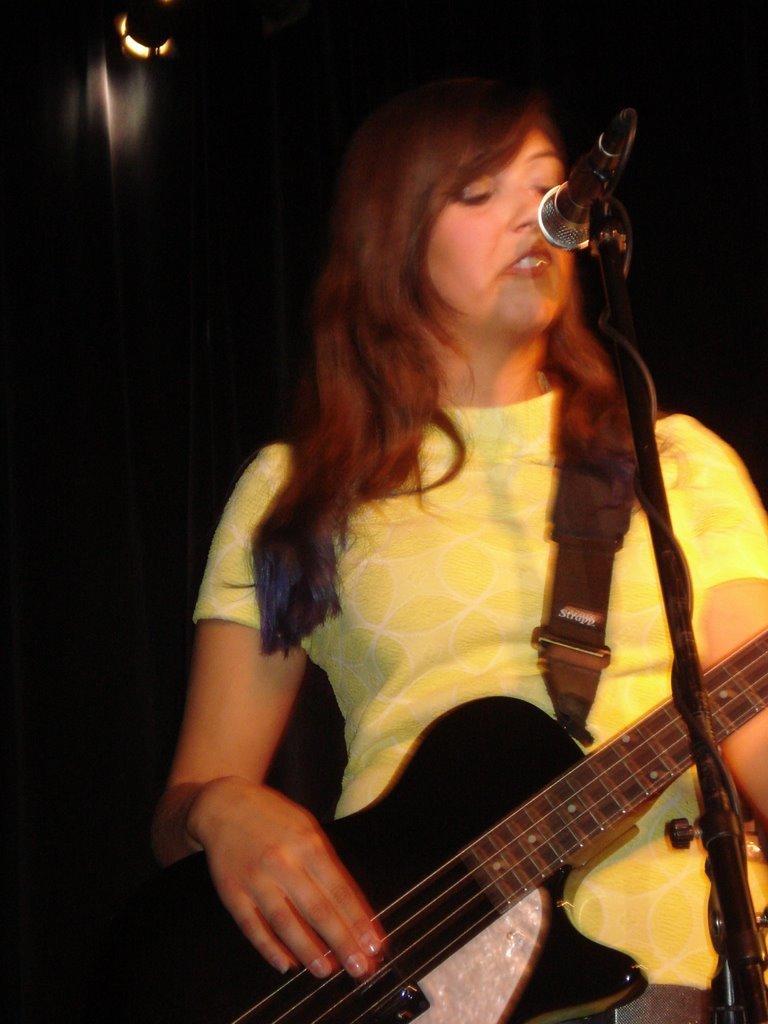Could you give a brief overview of what you see in this image? This woman is playing a guitar in-front of mic. This woman wore yellow t-shirt. This is mic with holder. 